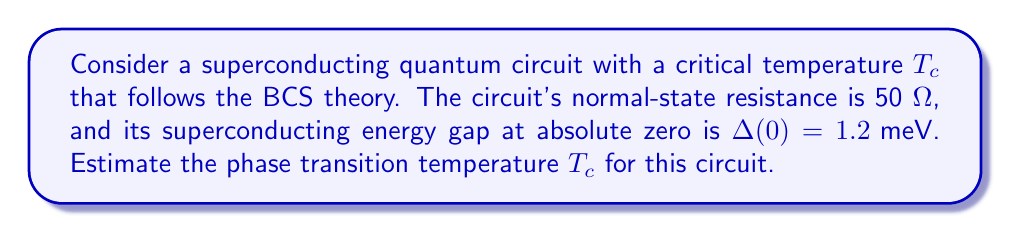Show me your answer to this math problem. To estimate the phase transition temperature $T_c$ for the superconducting quantum circuit, we'll use the BCS theory and the given information. Let's proceed step-by-step:

1. The BCS theory provides a relationship between the superconducting energy gap at absolute zero $\Delta(0)$ and the critical temperature $T_c$:

   $$\Delta(0) = 1.764 k_B T_c$$

   where $k_B$ is the Boltzmann constant.

2. We're given $\Delta(0) = 1.2 \text{ meV}$. Let's convert this to joules:
   
   $$\Delta(0) = 1.2 \times 10^{-3} \text{ eV} \times 1.602 \times 10^{-19} \text{ J/eV} = 1.9224 \times 10^{-22} \text{ J}$$

3. Now, let's substitute this into the BCS equation:

   $$1.9224 \times 10^{-22} \text{ J} = 1.764 \times (1.380649 \times 10^{-23} \text{ J/K}) \times T_c$$

4. Solving for $T_c$:

   $$T_c = \frac{1.9224 \times 10^{-22} \text{ J}}{1.764 \times 1.380649 \times 10^{-23} \text{ J/K}} = 7.89 \text{ K}$$

5. As a computer scientist familiar with system interactions, you might appreciate that this temperature corresponds to the point where the quantum circuit transitions from its normal state to its superconducting state, fundamentally changing its electrical properties and potential for quantum operations.
Answer: $T_c \approx 7.89 \text{ K}$ 